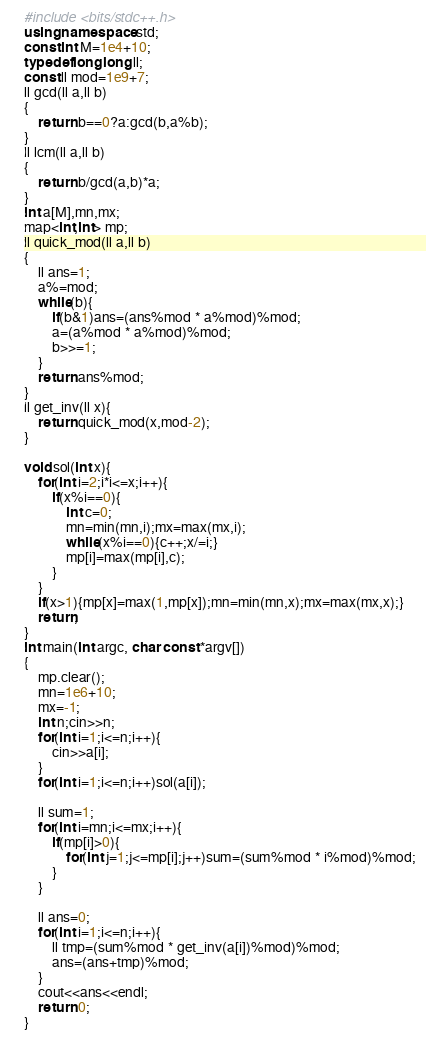<code> <loc_0><loc_0><loc_500><loc_500><_C++_>#include <bits/stdc++.h>
using namespace std;
const int M=1e4+10;
typedef long long ll;
const ll mod=1e9+7;
ll gcd(ll a,ll b)
{
	return b==0?a:gcd(b,a%b);
}
ll lcm(ll a,ll b)
{
	return b/gcd(a,b)*a;
}
int a[M],mn,mx;
map<int,int> mp;
ll quick_mod(ll a,ll b)
{
	ll ans=1;
	a%=mod;
	while(b){
		if(b&1)ans=(ans%mod * a%mod)%mod;
		a=(a%mod * a%mod)%mod;
		b>>=1;
	}
	return ans%mod;
}
ll get_inv(ll x){
	return quick_mod(x,mod-2);
}

void sol(int x){
	for(int i=2;i*i<=x;i++){
		if(x%i==0){
			int c=0;
			mn=min(mn,i);mx=max(mx,i);
			while(x%i==0){c++;x/=i;}
			mp[i]=max(mp[i],c);
		}
	}
	if(x>1){mp[x]=max(1,mp[x]);mn=min(mn,x);mx=max(mx,x);}
	return;
}
int main(int argc, char const *argv[])
{
	mp.clear();
	mn=1e6+10;
	mx=-1;
	int n;cin>>n;
	for(int i=1;i<=n;i++){
		cin>>a[i];
	}
	for(int i=1;i<=n;i++)sol(a[i]);
	
	ll sum=1;
	for(int i=mn;i<=mx;i++){
		if(mp[i]>0){
			for(int j=1;j<=mp[i];j++)sum=(sum%mod * i%mod)%mod;
		}
	}
	
	ll ans=0;
	for(int i=1;i<=n;i++){
		ll tmp=(sum%mod * get_inv(a[i])%mod)%mod;
		ans=(ans+tmp)%mod;
	}
	cout<<ans<<endl;
	return 0;
}
</code> 